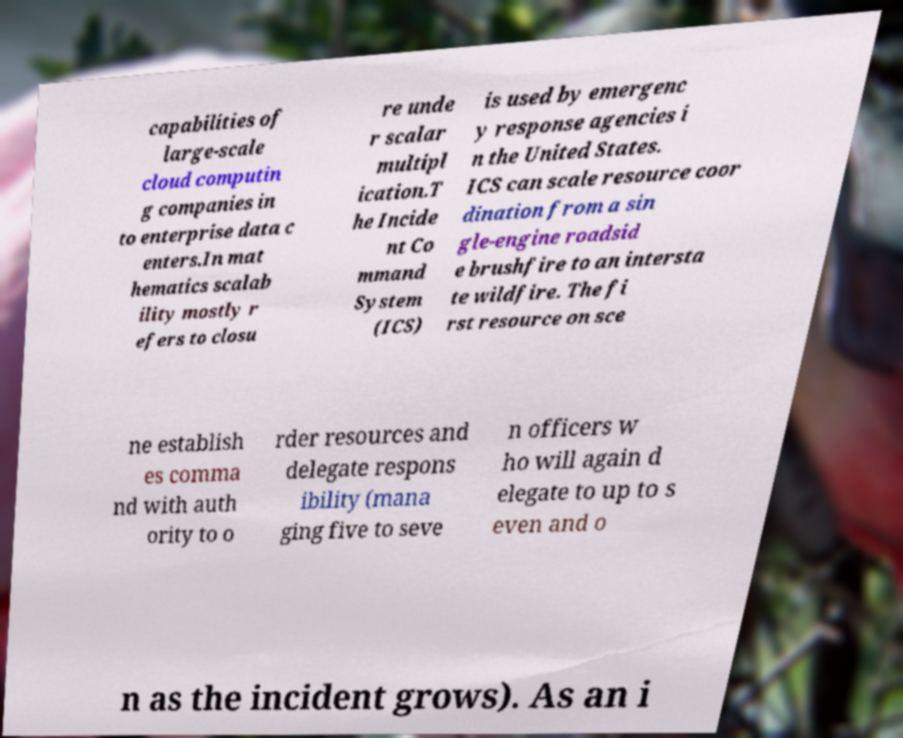Can you read and provide the text displayed in the image?This photo seems to have some interesting text. Can you extract and type it out for me? capabilities of large-scale cloud computin g companies in to enterprise data c enters.In mat hematics scalab ility mostly r efers to closu re unde r scalar multipl ication.T he Incide nt Co mmand System (ICS) is used by emergenc y response agencies i n the United States. ICS can scale resource coor dination from a sin gle-engine roadsid e brushfire to an intersta te wildfire. The fi rst resource on sce ne establish es comma nd with auth ority to o rder resources and delegate respons ibility (mana ging five to seve n officers w ho will again d elegate to up to s even and o n as the incident grows). As an i 